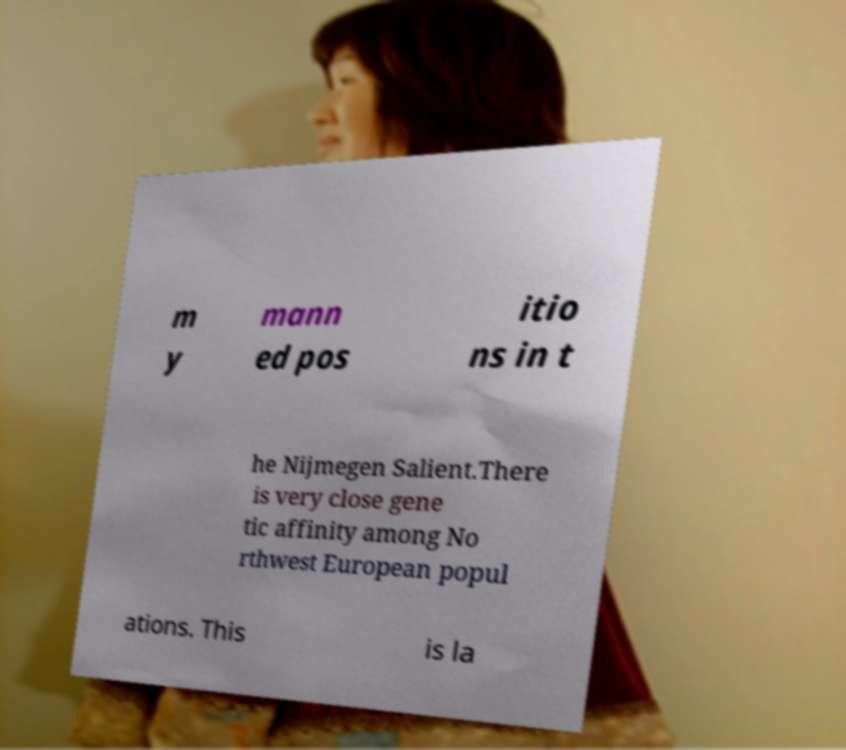Please identify and transcribe the text found in this image. m y mann ed pos itio ns in t he Nijmegen Salient.There is very close gene tic affinity among No rthwest European popul ations. This is la 